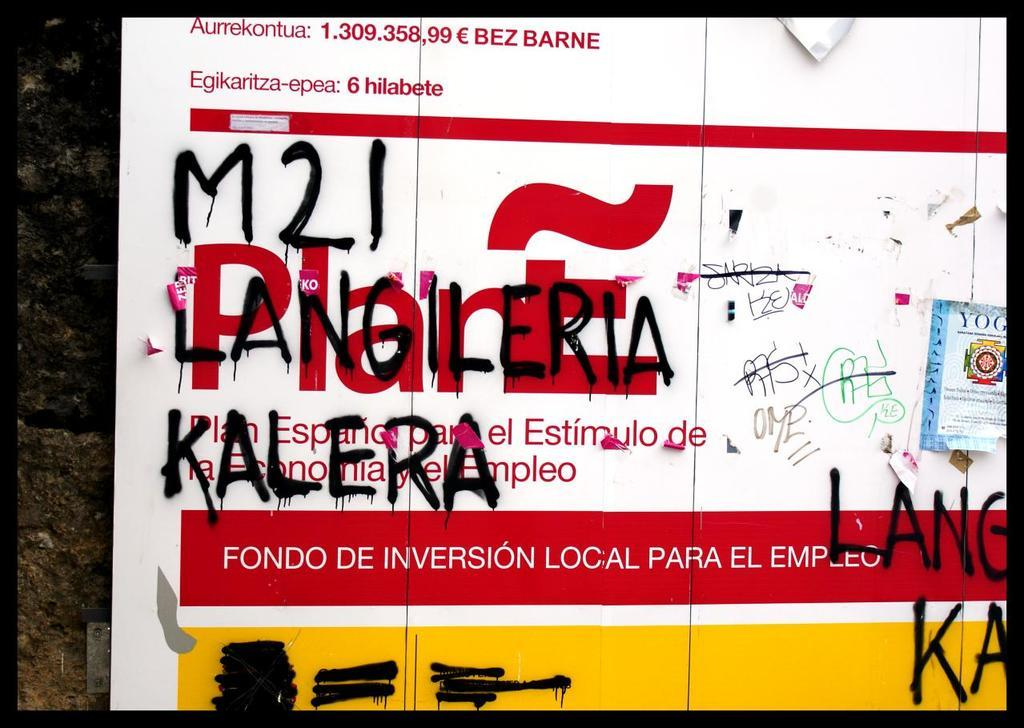<image>
Give a short and clear explanation of the subsequent image. Advertisement outside with graffitti written over the advertisement that says '121 LANGILERIA KALERA.' 